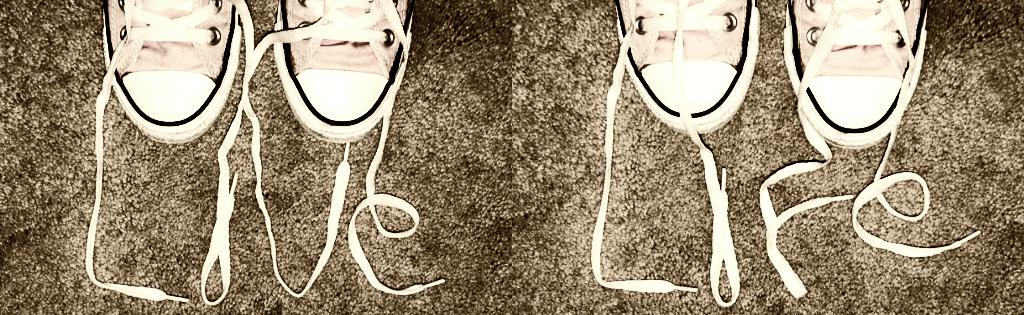What type of shoes can be seen in the image? There are two pairs of white canvas shoes in the image. Where are the shoes located? The shoes are on the road. What color is the nose of the person wearing the shoes in the image? There is no person wearing the shoes in the image, and therefore no nose can be observed. How many people are wearing the shoes in the image? The image only shows the shoes themselves, not the people wearing them, so it is impossible to determine the number of people wearing the shoes. 